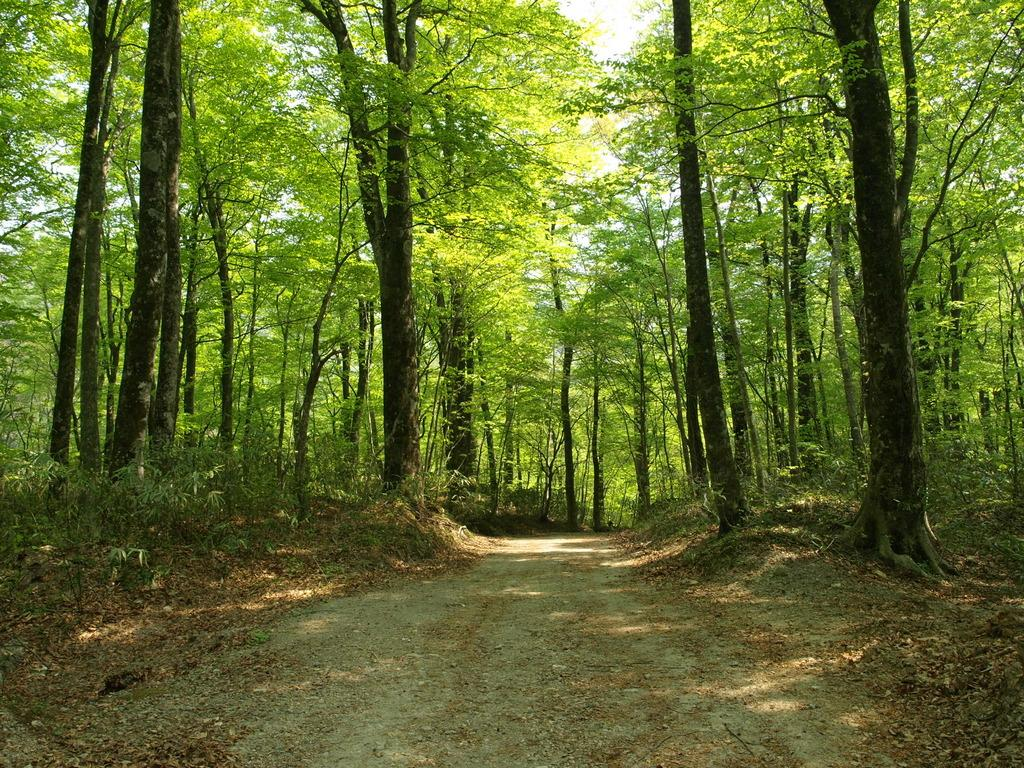What type of natural elements can be seen in the image? There are many trees and plants in the image. What kind of path is visible in the image? There is a walkway in the image. Where is the library located in the image? There is no library present in the image. How does the van maintain its balance on the walkway in the image? There is no van present in the image, so the question of balance is not applicable. 